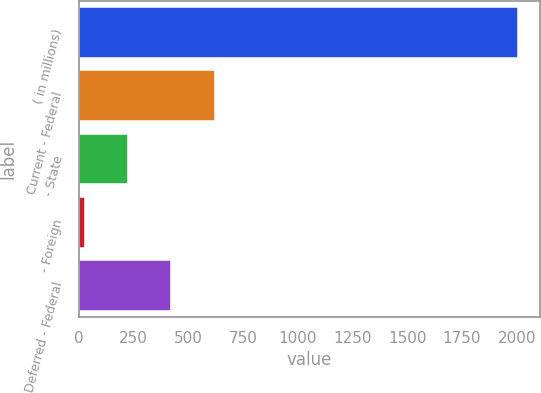Convert chart to OTSL. <chart><loc_0><loc_0><loc_500><loc_500><bar_chart><fcel>( in millions)<fcel>Current - Federal<fcel>- State<fcel>- Foreign<fcel>Deferred - Federal<nl><fcel>2004<fcel>621.5<fcel>226.5<fcel>29<fcel>424<nl></chart> 